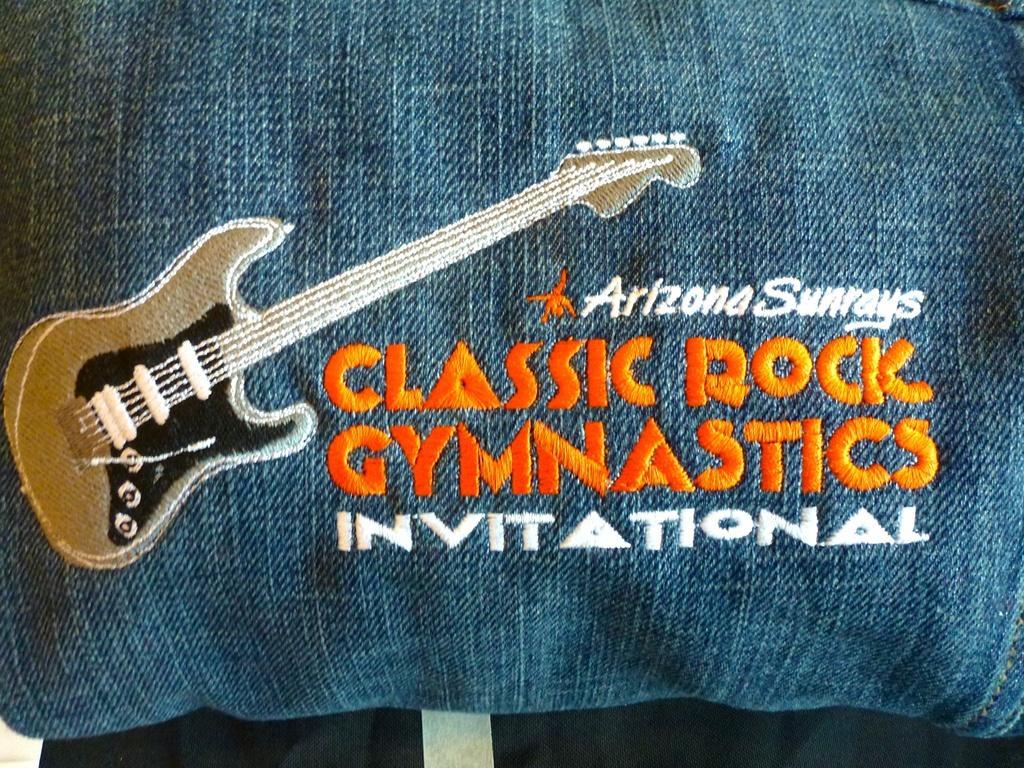Please provide a concise description of this image. In this picture I can see there is a cloth and there is an image of the guitar and there is something written on it. There is a black object at the bottom of the image. 